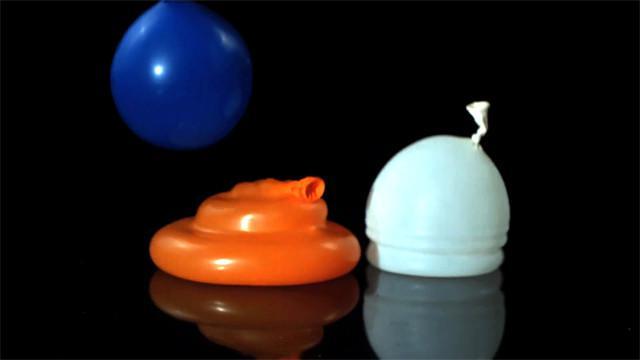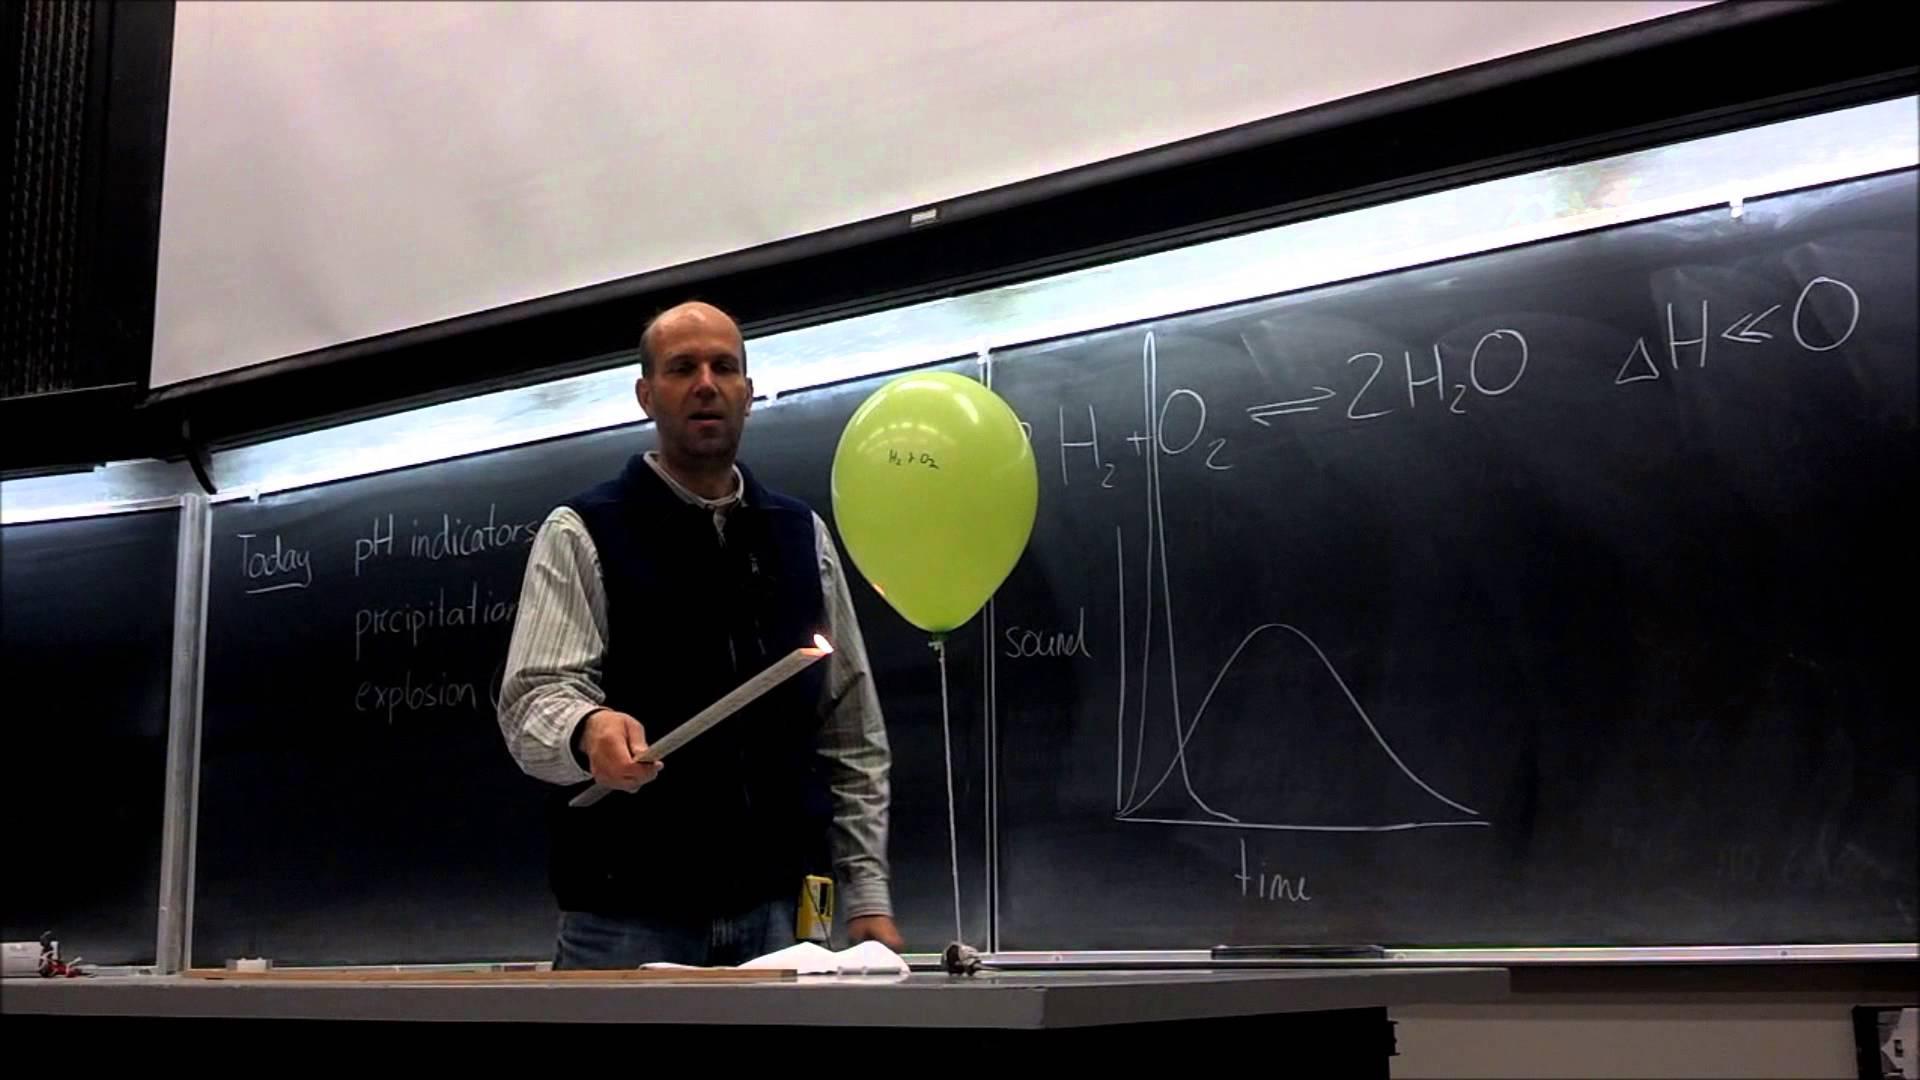The first image is the image on the left, the second image is the image on the right. For the images shown, is this caption "One image shows exactly one human interacting with a single balloon in what could be a science demonstration, while the other image shows exactly three balloons." true? Answer yes or no. Yes. The first image is the image on the left, the second image is the image on the right. Considering the images on both sides, is "The image on the right contains at least one blue balloon." valid? Answer yes or no. No. 